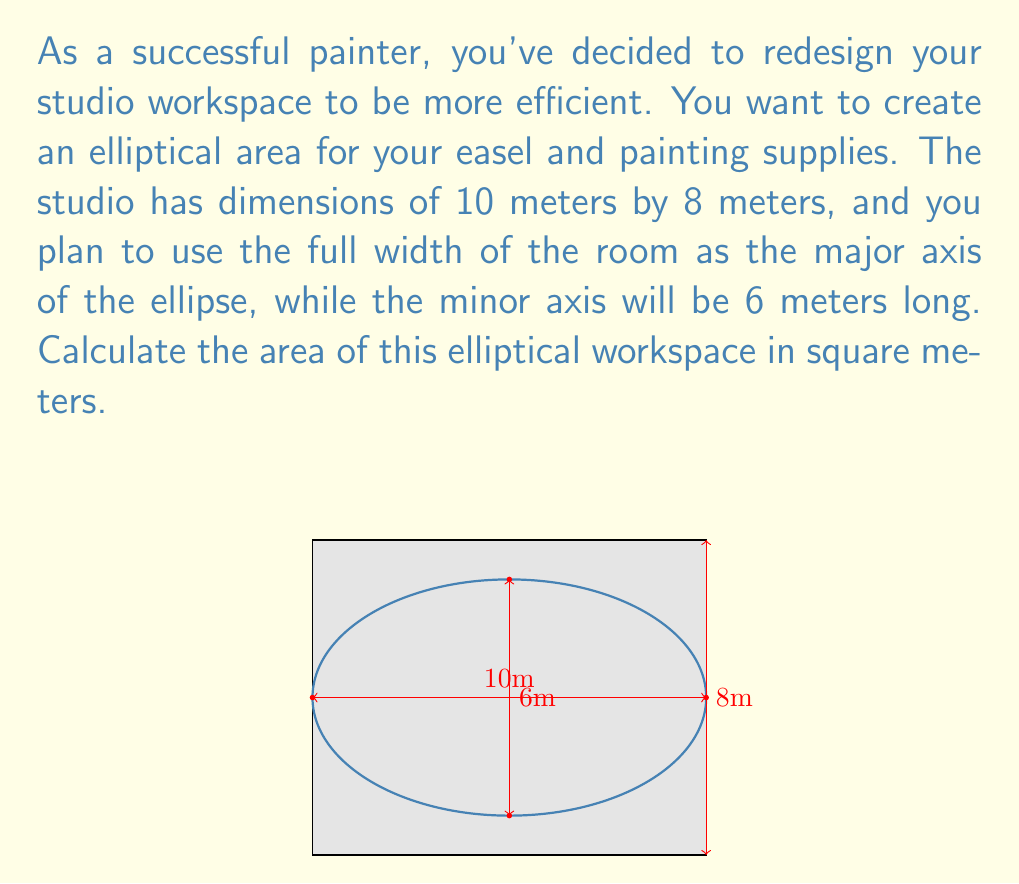Show me your answer to this math problem. Let's approach this step-by-step:

1) The formula for the area of an ellipse is:

   $$A = \pi ab$$

   where $a$ is half the length of the major axis and $b$ is half the length of the minor axis.

2) From the given information:
   - The major axis is the full width of the room, which is 10 meters.
   - The minor axis is given as 6 meters.

3) Therefore:
   $a = 10/2 = 5$ meters
   $b = 6/2 = 3$ meters

4) Substituting these values into our formula:

   $$A = \pi (5)(3)$$

5) Simplify:
   $$A = 15\pi$$

6) If we want to give a decimal approximation:
   $$A \approx 47.12389 \text{ square meters}$$

Thus, the area of the elliptical workspace is $15\pi$ or approximately 47.12 square meters.
Answer: $15\pi$ sq m (or approx. 47.12 sq m) 